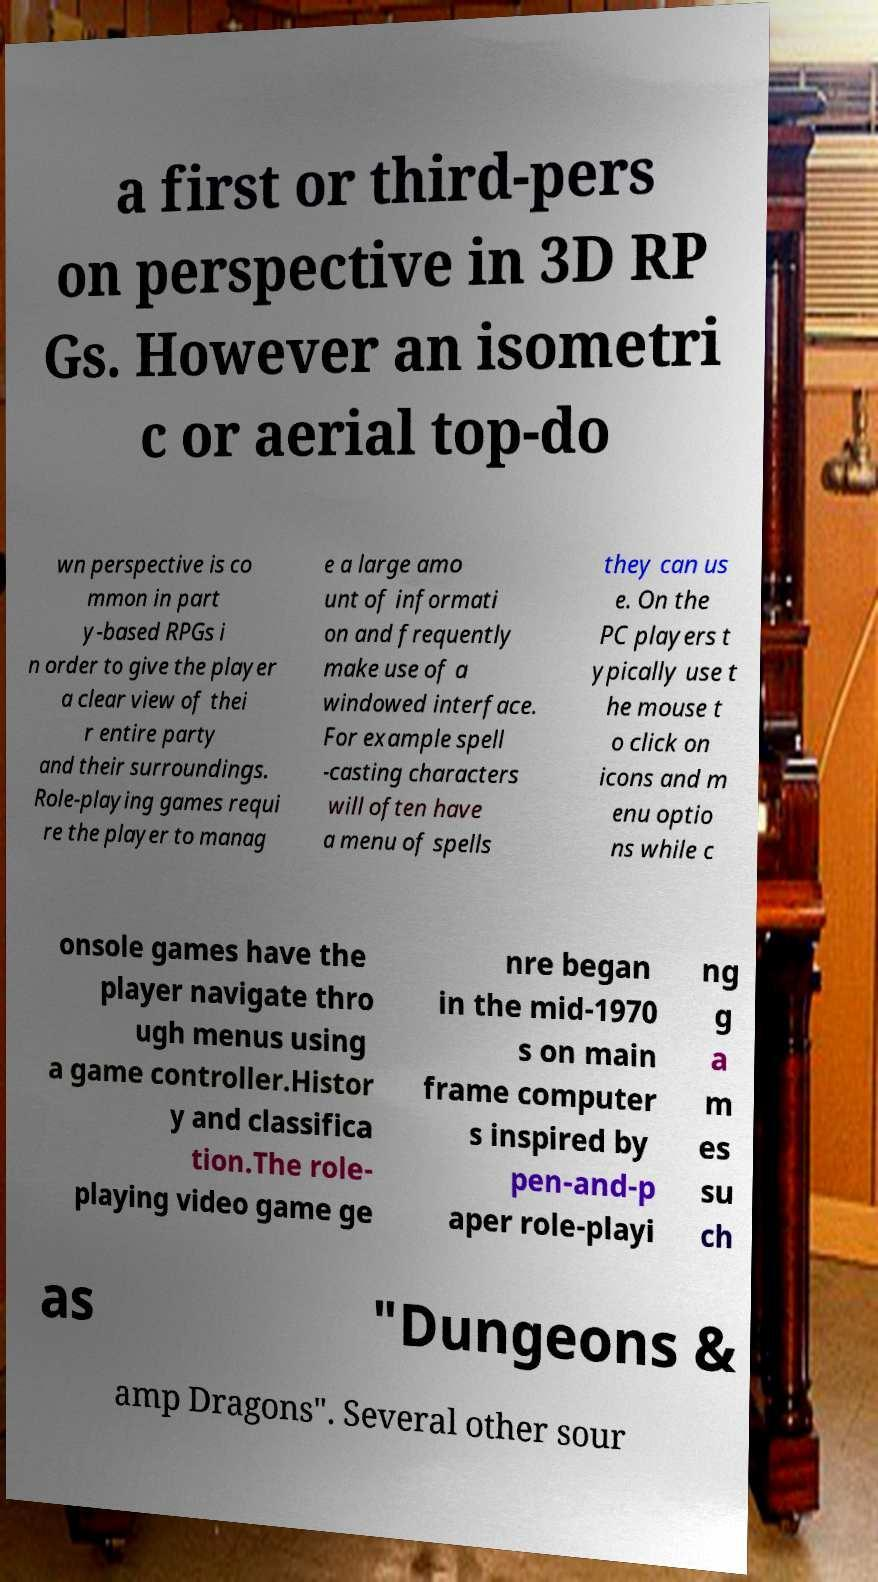What messages or text are displayed in this image? I need them in a readable, typed format. a first or third-pers on perspective in 3D RP Gs. However an isometri c or aerial top-do wn perspective is co mmon in part y-based RPGs i n order to give the player a clear view of thei r entire party and their surroundings. Role-playing games requi re the player to manag e a large amo unt of informati on and frequently make use of a windowed interface. For example spell -casting characters will often have a menu of spells they can us e. On the PC players t ypically use t he mouse t o click on icons and m enu optio ns while c onsole games have the player navigate thro ugh menus using a game controller.Histor y and classifica tion.The role- playing video game ge nre began in the mid-1970 s on main frame computer s inspired by pen-and-p aper role-playi ng g a m es su ch as "Dungeons & amp Dragons". Several other sour 